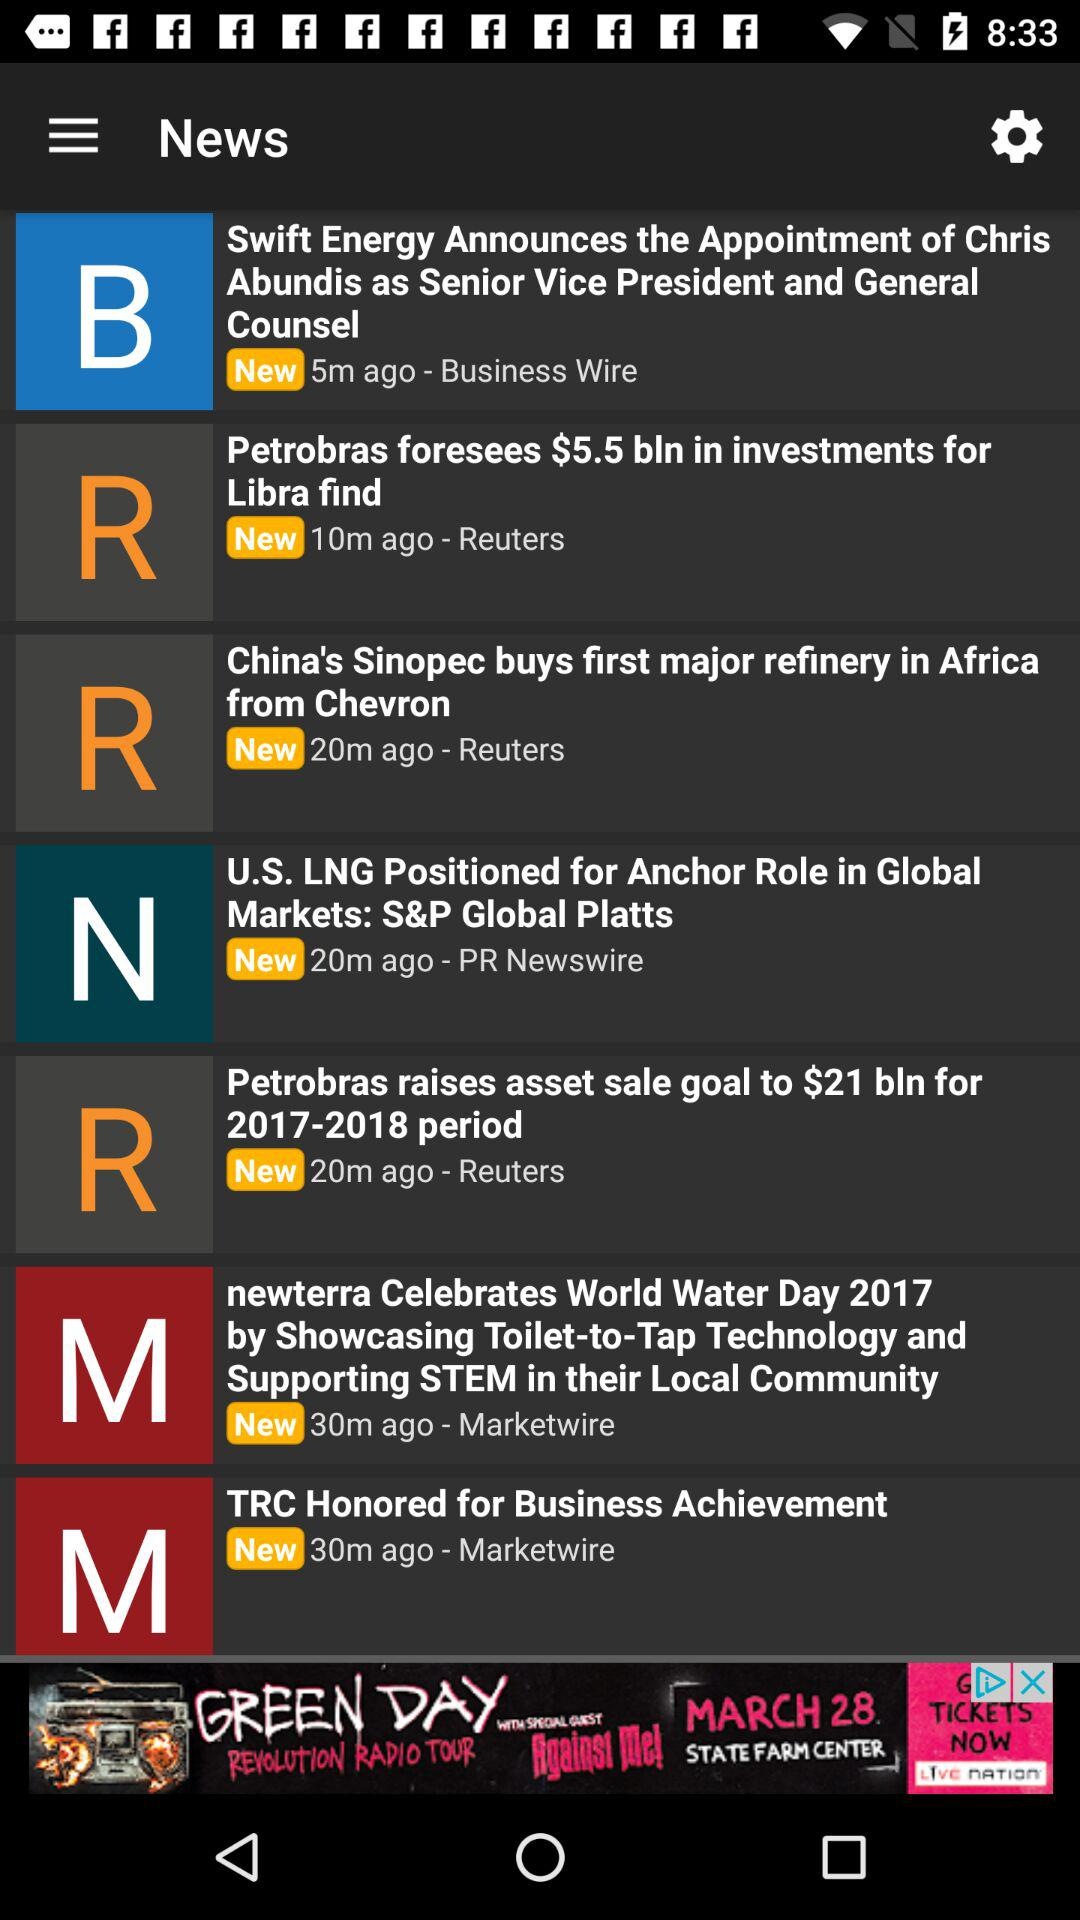How many minutes ago was the news "TRC Honored for Business Achievement" published? The news "TRC Honored for Business Achievement" was published 30 minutes ago. 